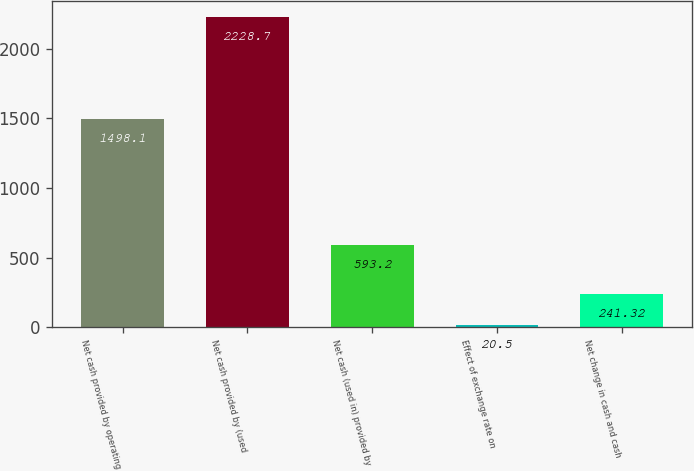Convert chart. <chart><loc_0><loc_0><loc_500><loc_500><bar_chart><fcel>Net cash provided by operating<fcel>Net cash provided by (used<fcel>Net cash (used in) provided by<fcel>Effect of exchange rate on<fcel>Net change in cash and cash<nl><fcel>1498.1<fcel>2228.7<fcel>593.2<fcel>20.5<fcel>241.32<nl></chart> 